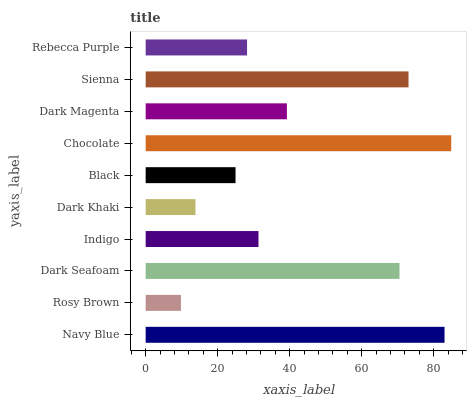Is Rosy Brown the minimum?
Answer yes or no. Yes. Is Chocolate the maximum?
Answer yes or no. Yes. Is Dark Seafoam the minimum?
Answer yes or no. No. Is Dark Seafoam the maximum?
Answer yes or no. No. Is Dark Seafoam greater than Rosy Brown?
Answer yes or no. Yes. Is Rosy Brown less than Dark Seafoam?
Answer yes or no. Yes. Is Rosy Brown greater than Dark Seafoam?
Answer yes or no. No. Is Dark Seafoam less than Rosy Brown?
Answer yes or no. No. Is Dark Magenta the high median?
Answer yes or no. Yes. Is Indigo the low median?
Answer yes or no. Yes. Is Dark Khaki the high median?
Answer yes or no. No. Is Navy Blue the low median?
Answer yes or no. No. 